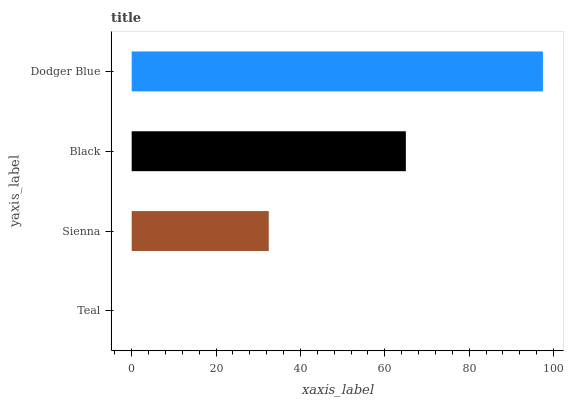Is Teal the minimum?
Answer yes or no. Yes. Is Dodger Blue the maximum?
Answer yes or no. Yes. Is Sienna the minimum?
Answer yes or no. No. Is Sienna the maximum?
Answer yes or no. No. Is Sienna greater than Teal?
Answer yes or no. Yes. Is Teal less than Sienna?
Answer yes or no. Yes. Is Teal greater than Sienna?
Answer yes or no. No. Is Sienna less than Teal?
Answer yes or no. No. Is Black the high median?
Answer yes or no. Yes. Is Sienna the low median?
Answer yes or no. Yes. Is Teal the high median?
Answer yes or no. No. Is Teal the low median?
Answer yes or no. No. 